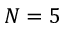Convert formula to latex. <formula><loc_0><loc_0><loc_500><loc_500>N = 5</formula> 